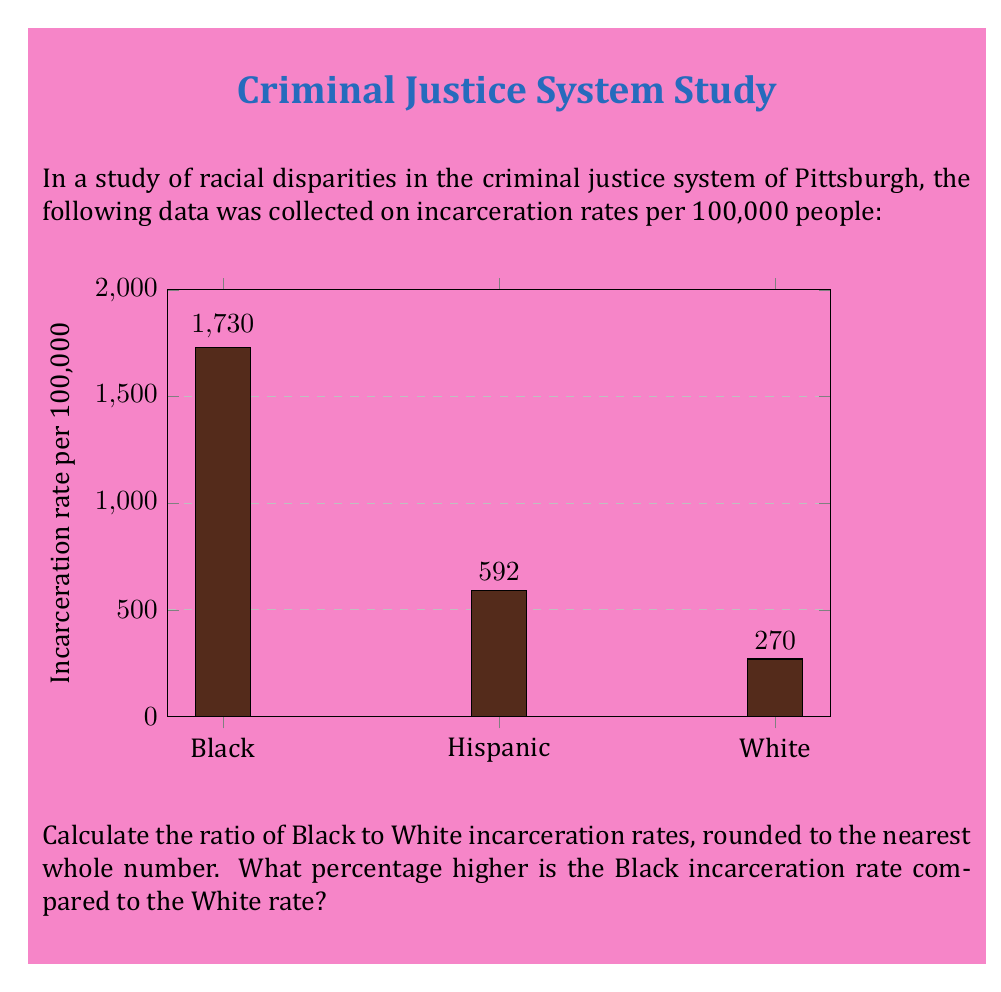Give your solution to this math problem. Let's approach this step-by-step:

1) First, we need to calculate the ratio of Black to White incarceration rates:

   $\text{Ratio} = \frac{\text{Black rate}}{\text{White rate}} = \frac{1730}{270} \approx 6.407$

   Rounding to the nearest whole number: 6

2) To calculate the percentage difference, we use the formula:

   $\text{Percentage difference} = \frac{\text{Difference}}{\text{Original}} \times 100\%$

   Where the difference is (Black rate - White rate) and the original is the White rate.

3) Let's plug in the numbers:

   $\text{Percentage difference} = \frac{1730 - 270}{270} \times 100\%$

4) Simplify:
   
   $= \frac{1460}{270} \times 100\%$
   
   $= 5.4074 \times 100\%$
   
   $= 540.74\%$

5) Rounding to the nearest whole number: 541%

Therefore, the Black incarceration rate is 541% higher than the White incarceration rate.
Answer: 6; 541% 